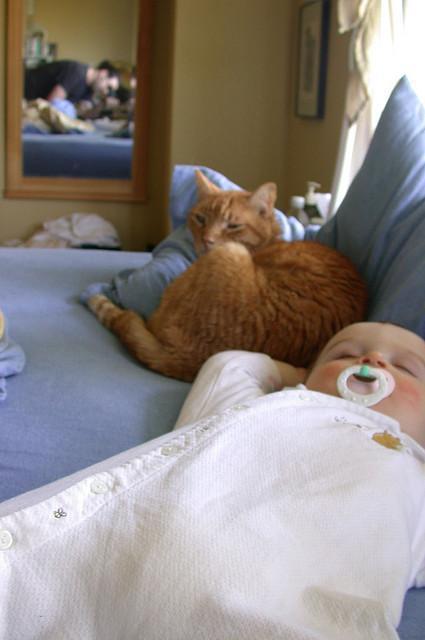How many beds are there?
Give a very brief answer. 2. How many people are there?
Give a very brief answer. 2. 